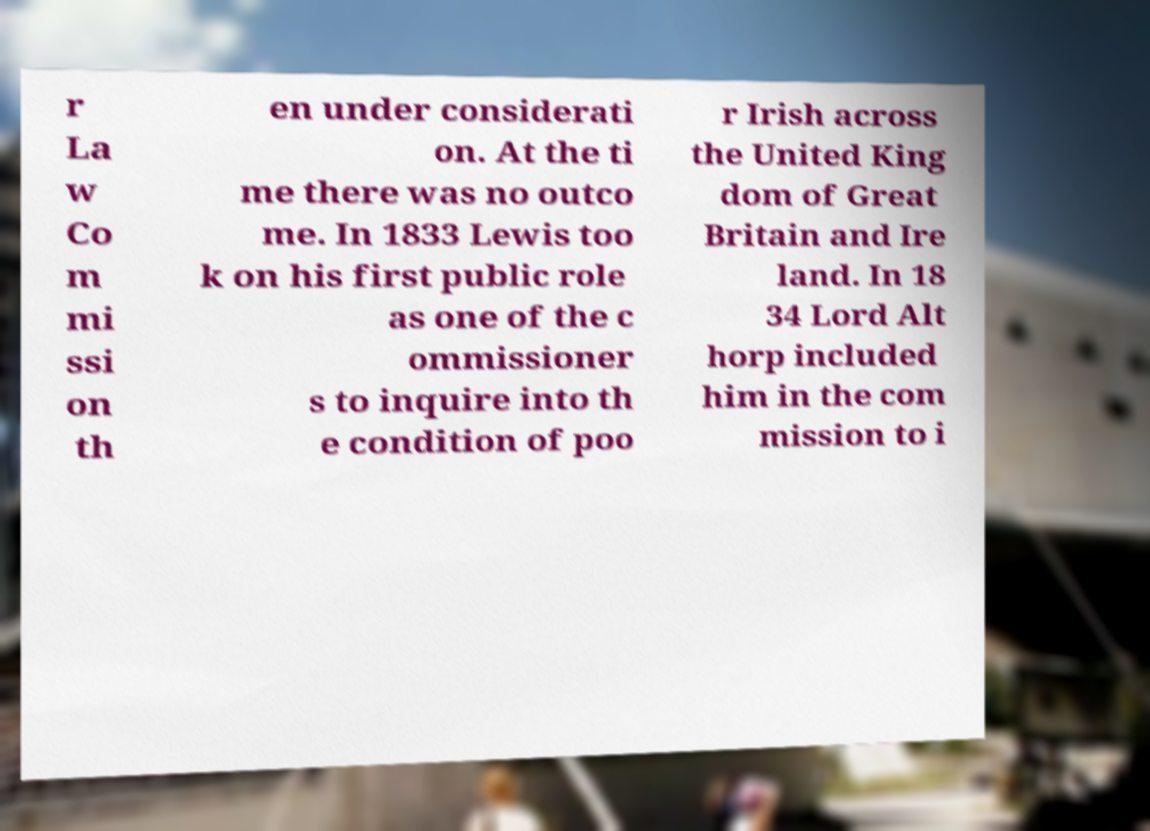Please read and relay the text visible in this image. What does it say? r La w Co m mi ssi on th en under considerati on. At the ti me there was no outco me. In 1833 Lewis too k on his first public role as one of the c ommissioner s to inquire into th e condition of poo r Irish across the United King dom of Great Britain and Ire land. In 18 34 Lord Alt horp included him in the com mission to i 